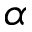Convert formula to latex. <formula><loc_0><loc_0><loc_500><loc_500>\alpha</formula> 